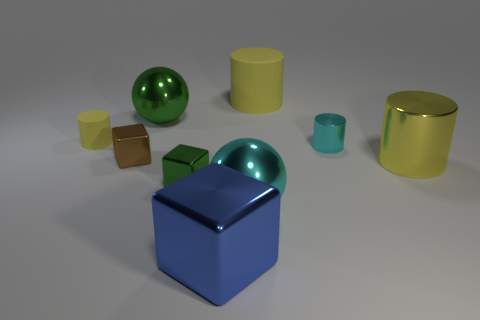Subtract all brown blocks. How many yellow cylinders are left? 3 Subtract all small matte cylinders. How many cylinders are left? 3 Subtract all cyan cylinders. How many cylinders are left? 3 Add 1 cyan cylinders. How many objects exist? 10 Subtract all spheres. How many objects are left? 7 Subtract all green cylinders. Subtract all blue spheres. How many cylinders are left? 4 Subtract all tiny objects. Subtract all tiny blue rubber balls. How many objects are left? 5 Add 5 large yellow matte cylinders. How many large yellow matte cylinders are left? 6 Add 6 purple spheres. How many purple spheres exist? 6 Subtract 0 gray blocks. How many objects are left? 9 